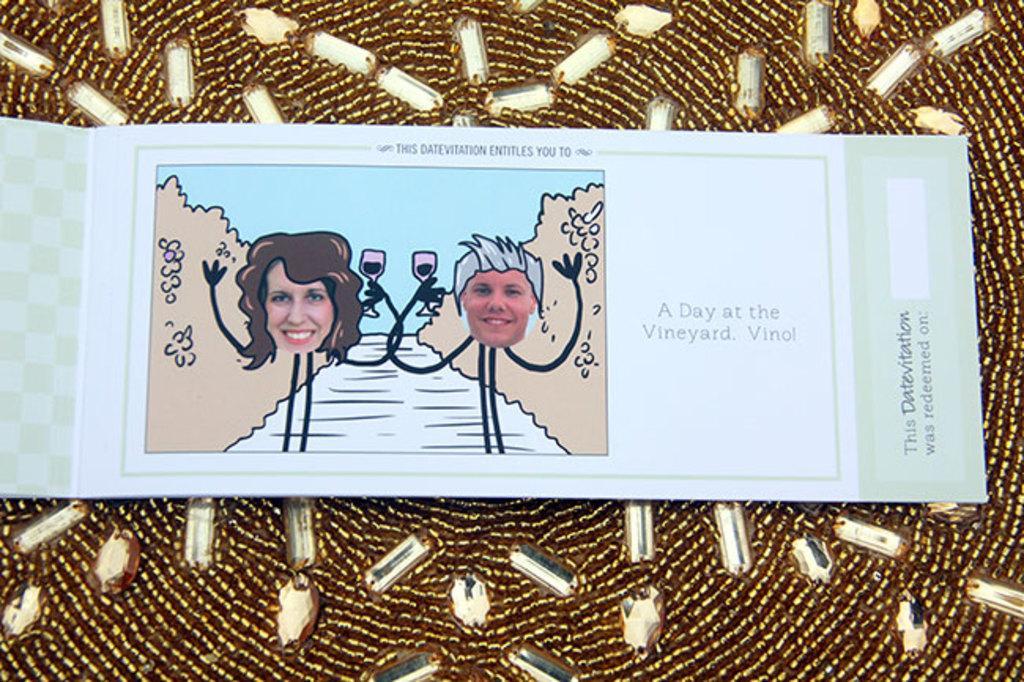Please provide a concise description of this image. In this image we can see the entitles book with the text and also pictures and it is placed on the decorated kundans cloth. 